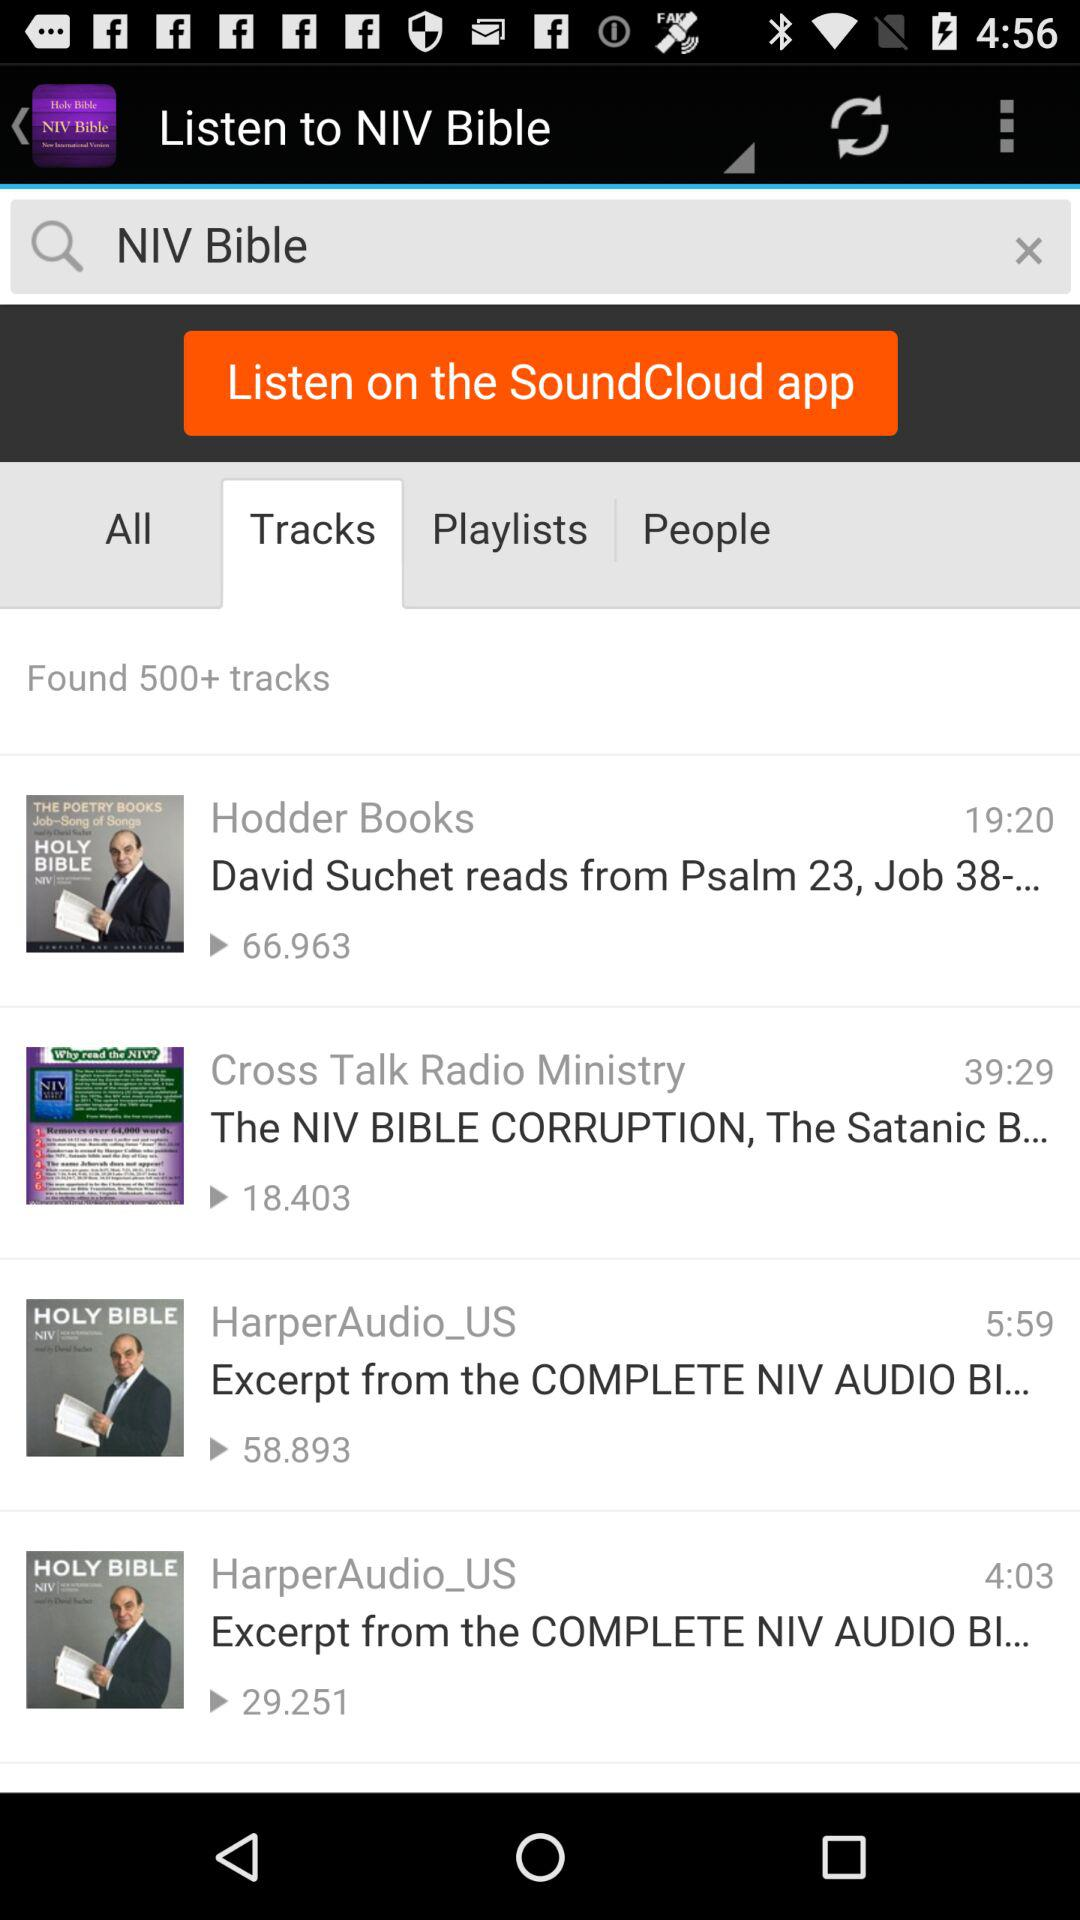How many tracks are there? There are more than 500 tracks. 